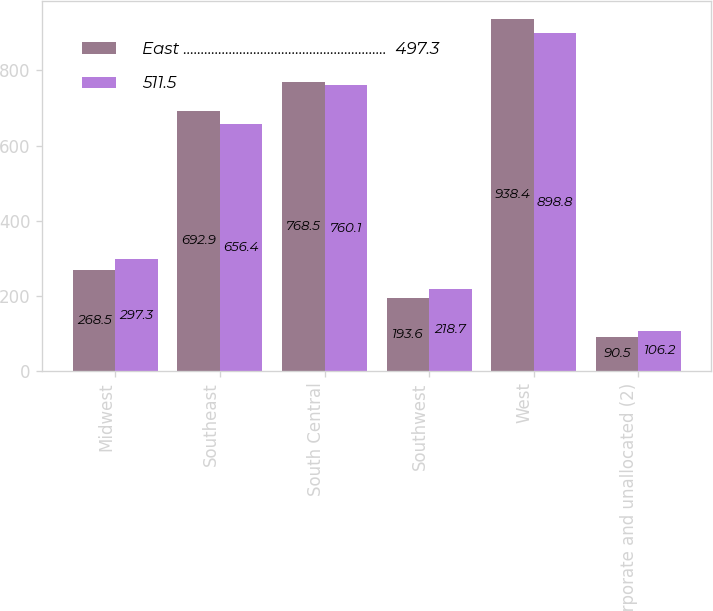Convert chart to OTSL. <chart><loc_0><loc_0><loc_500><loc_500><stacked_bar_chart><ecel><fcel>Midwest<fcel>Southeast<fcel>South Central<fcel>Southwest<fcel>West<fcel>Corporate and unallocated (2)<nl><fcel>East ..........................................................  497.3<fcel>268.5<fcel>692.9<fcel>768.5<fcel>193.6<fcel>938.4<fcel>90.5<nl><fcel>511.5<fcel>297.3<fcel>656.4<fcel>760.1<fcel>218.7<fcel>898.8<fcel>106.2<nl></chart> 